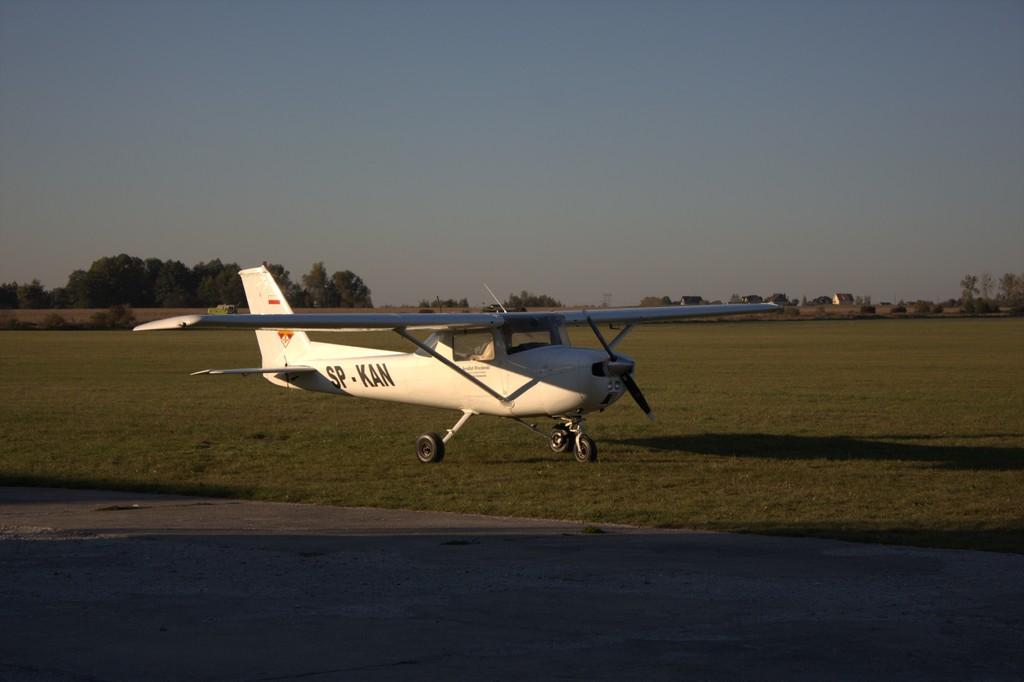What is the planes call number?
Give a very brief answer. Sp-kan. 